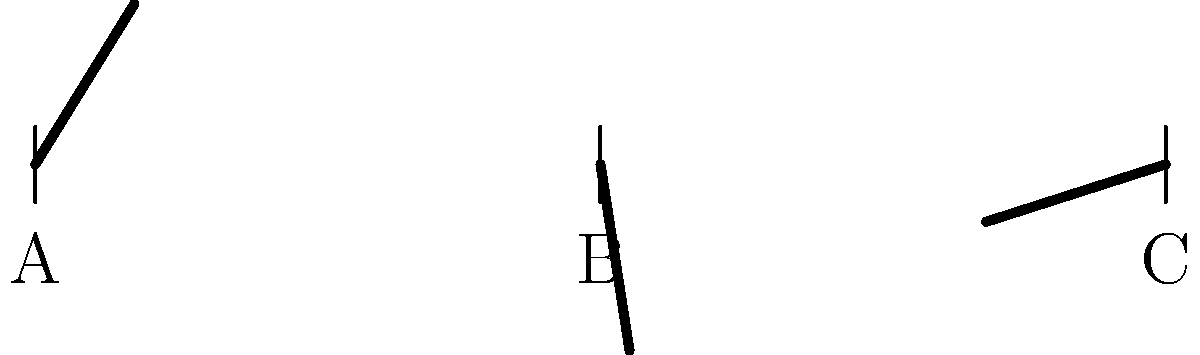The silhouettes above represent the beak profiles of three different bird species. Given that the angle of inclination for species A is 45°, determine the difference between the angles of inclination for species B and C. To solve this problem, we need to follow these steps:

1. Identify the given information:
   - Species A has an angle of inclination of 45°
   - We need to find the difference between the angles of B and C

2. Estimate the angles for species B and C based on visual comparison with A:
   - Species B appears to have a smaller angle than A
   - Species C appears to have a larger angle than A

3. Approximate the angles for B and C:
   - B looks to be about 2/3 of A's angle: $45° * (2/3) ≈ 30°$
   - C looks to be about 4/3 of A's angle: $45° * (4/3) = 60°$

4. Calculate the difference between C and B:
   $60° - 30° = 30°$

Therefore, the difference between the angles of inclination for species B and C is approximately 30°.
Answer: 30° 